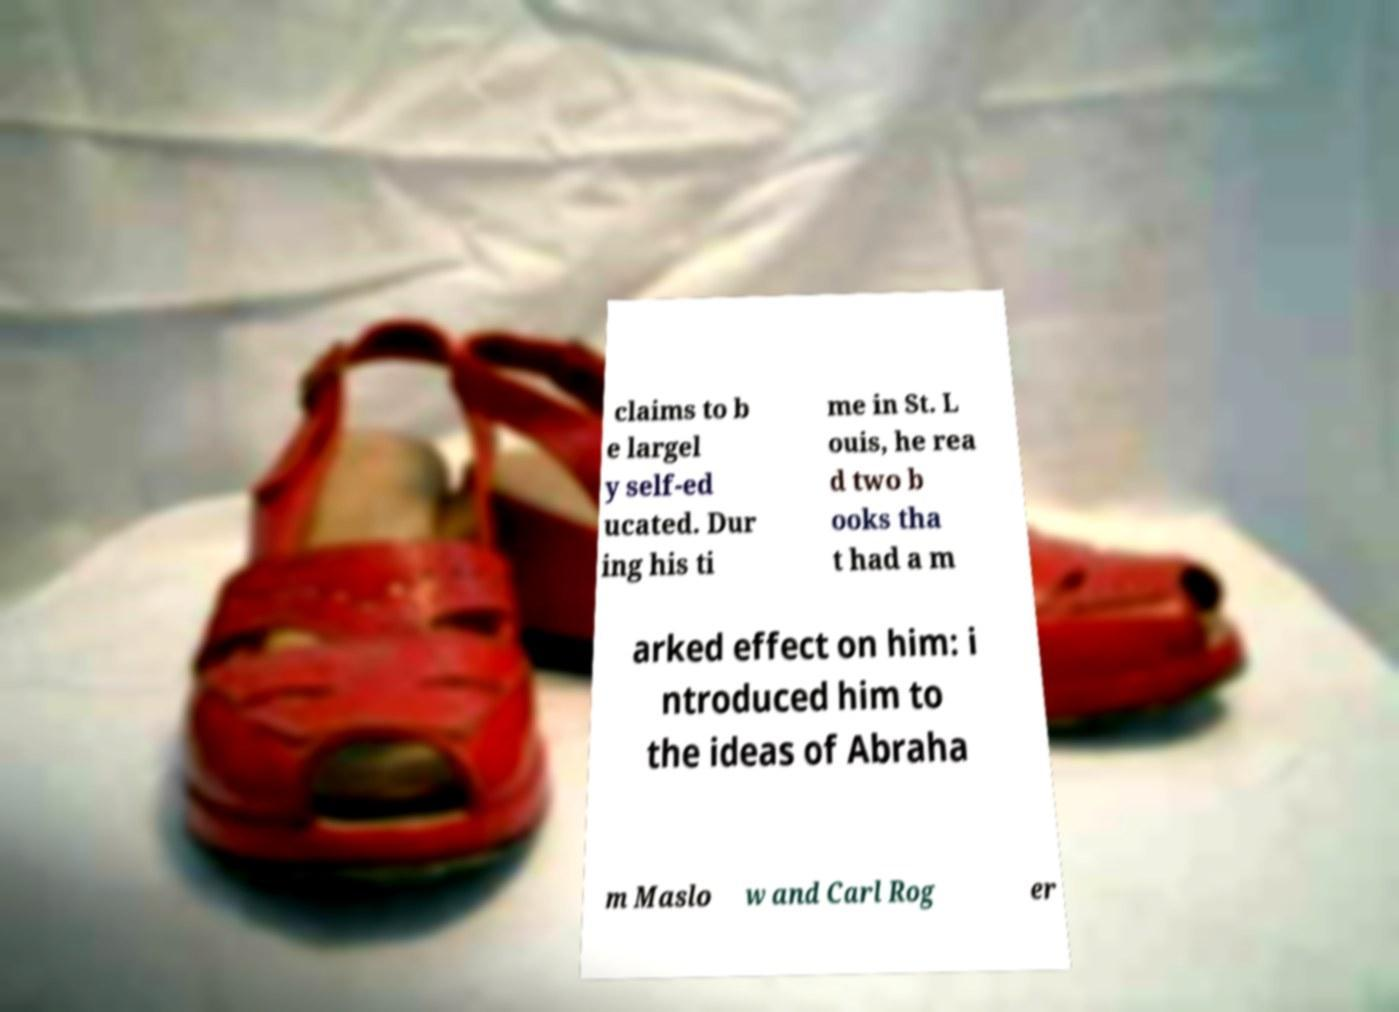Can you read and provide the text displayed in the image?This photo seems to have some interesting text. Can you extract and type it out for me? claims to b e largel y self-ed ucated. Dur ing his ti me in St. L ouis, he rea d two b ooks tha t had a m arked effect on him: i ntroduced him to the ideas of Abraha m Maslo w and Carl Rog er 